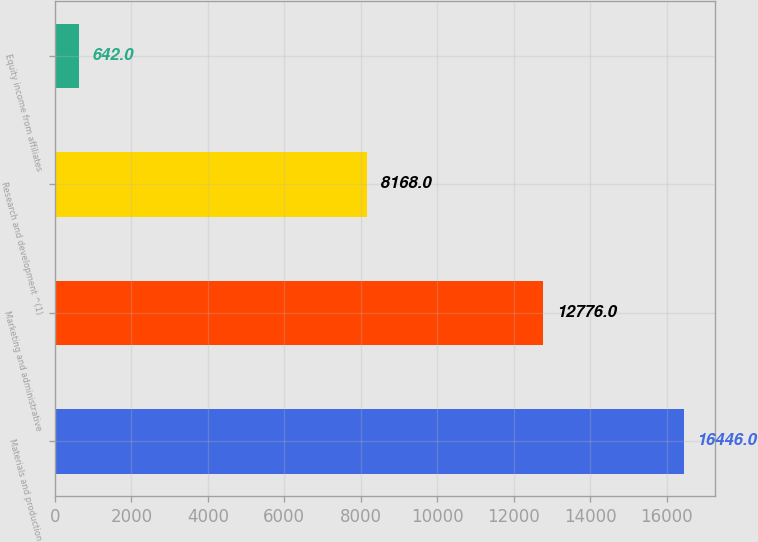Convert chart. <chart><loc_0><loc_0><loc_500><loc_500><bar_chart><fcel>Materials and production<fcel>Marketing and administrative<fcel>Research and development ^(1)<fcel>Equity income from affiliates<nl><fcel>16446<fcel>12776<fcel>8168<fcel>642<nl></chart> 